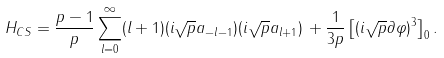<formula> <loc_0><loc_0><loc_500><loc_500>H _ { C S } = \frac { p - 1 } { p } \sum _ { l = 0 } ^ { \infty } ( l + 1 ) ( i \sqrt { p } a _ { - l - 1 } ) ( i \sqrt { p } a _ { l + 1 } ) \, + \frac { 1 } { 3 p } \left [ ( i \sqrt { p } \partial \varphi ) ^ { 3 } \right ] _ { 0 } .</formula> 